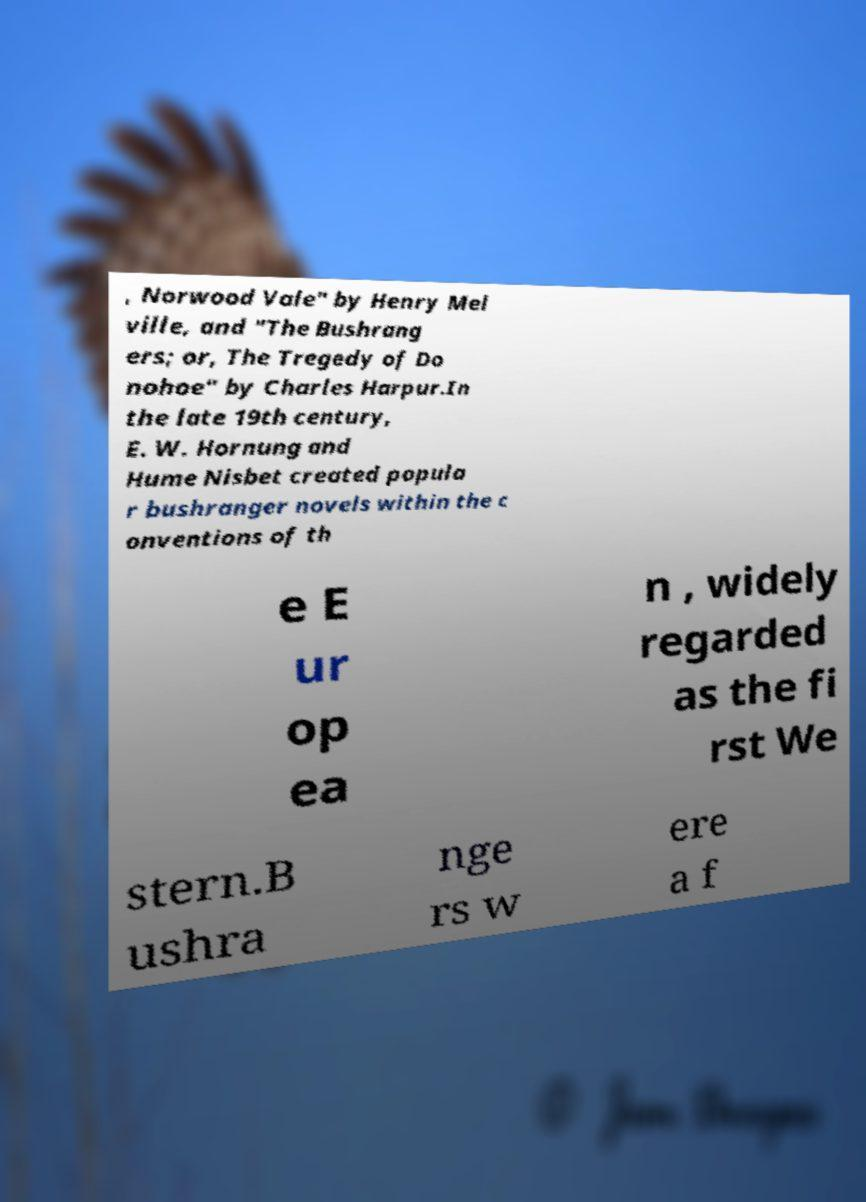Please identify and transcribe the text found in this image. , Norwood Vale" by Henry Mel ville, and "The Bushrang ers; or, The Tregedy of Do nohoe" by Charles Harpur.In the late 19th century, E. W. Hornung and Hume Nisbet created popula r bushranger novels within the c onventions of th e E ur op ea n , widely regarded as the fi rst We stern.B ushra nge rs w ere a f 